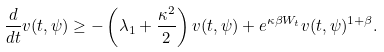<formula> <loc_0><loc_0><loc_500><loc_500>\frac { d } { d t } v ( t , \psi ) \geq - \left ( \lambda _ { 1 } + \frac { \kappa ^ { 2 } } { 2 } \right ) v ( t , \psi ) + e ^ { \kappa \beta W _ { t } } v ( t , \psi ) ^ { 1 + \beta } .</formula> 